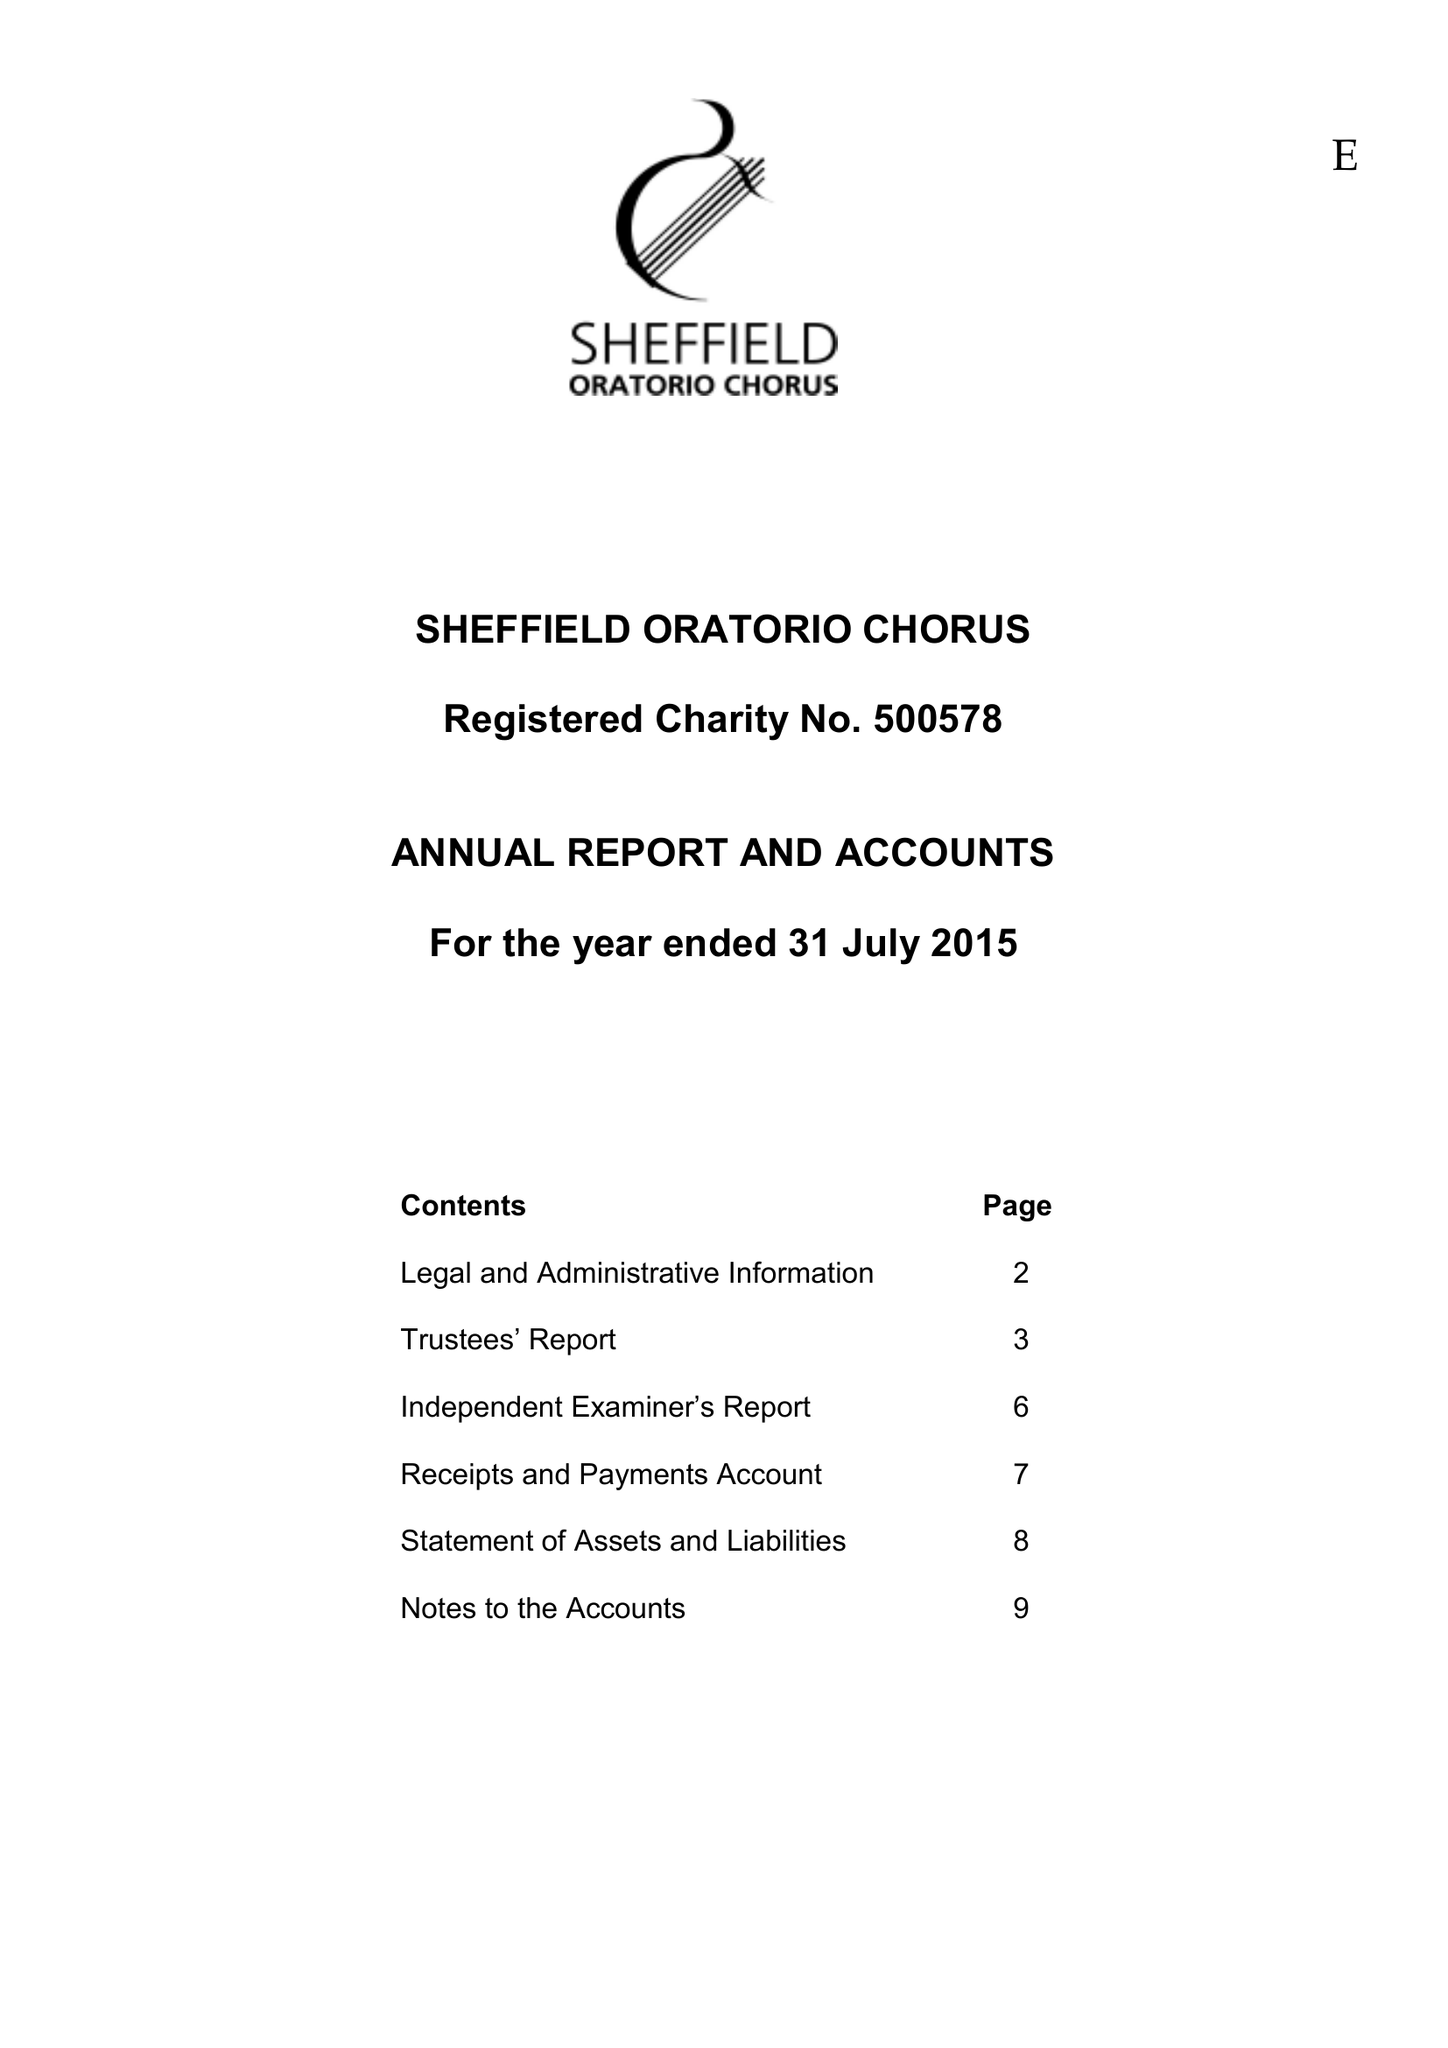What is the value for the income_annually_in_british_pounds?
Answer the question using a single word or phrase. 55216.00 